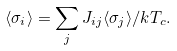Convert formula to latex. <formula><loc_0><loc_0><loc_500><loc_500>\langle \sigma _ { i } \rangle = \sum _ { j } J _ { i j } \langle \sigma _ { j } \rangle / k T _ { c } .</formula> 